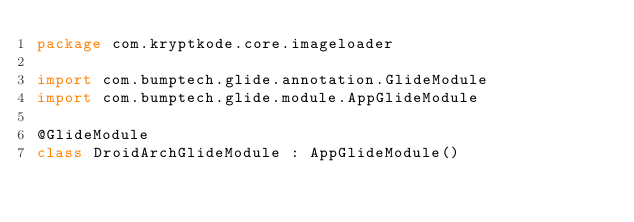<code> <loc_0><loc_0><loc_500><loc_500><_Kotlin_>package com.kryptkode.core.imageloader

import com.bumptech.glide.annotation.GlideModule
import com.bumptech.glide.module.AppGlideModule

@GlideModule
class DroidArchGlideModule : AppGlideModule()
</code> 